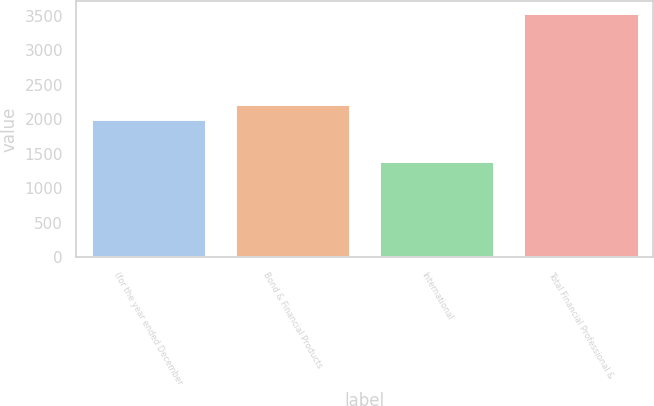<chart> <loc_0><loc_0><loc_500><loc_500><bar_chart><fcel>(for the year ended December<fcel>Bond & Financial Products<fcel>International<fcel>Total Financial Professional &<nl><fcel>2010<fcel>2223.3<fcel>1401<fcel>3534<nl></chart> 